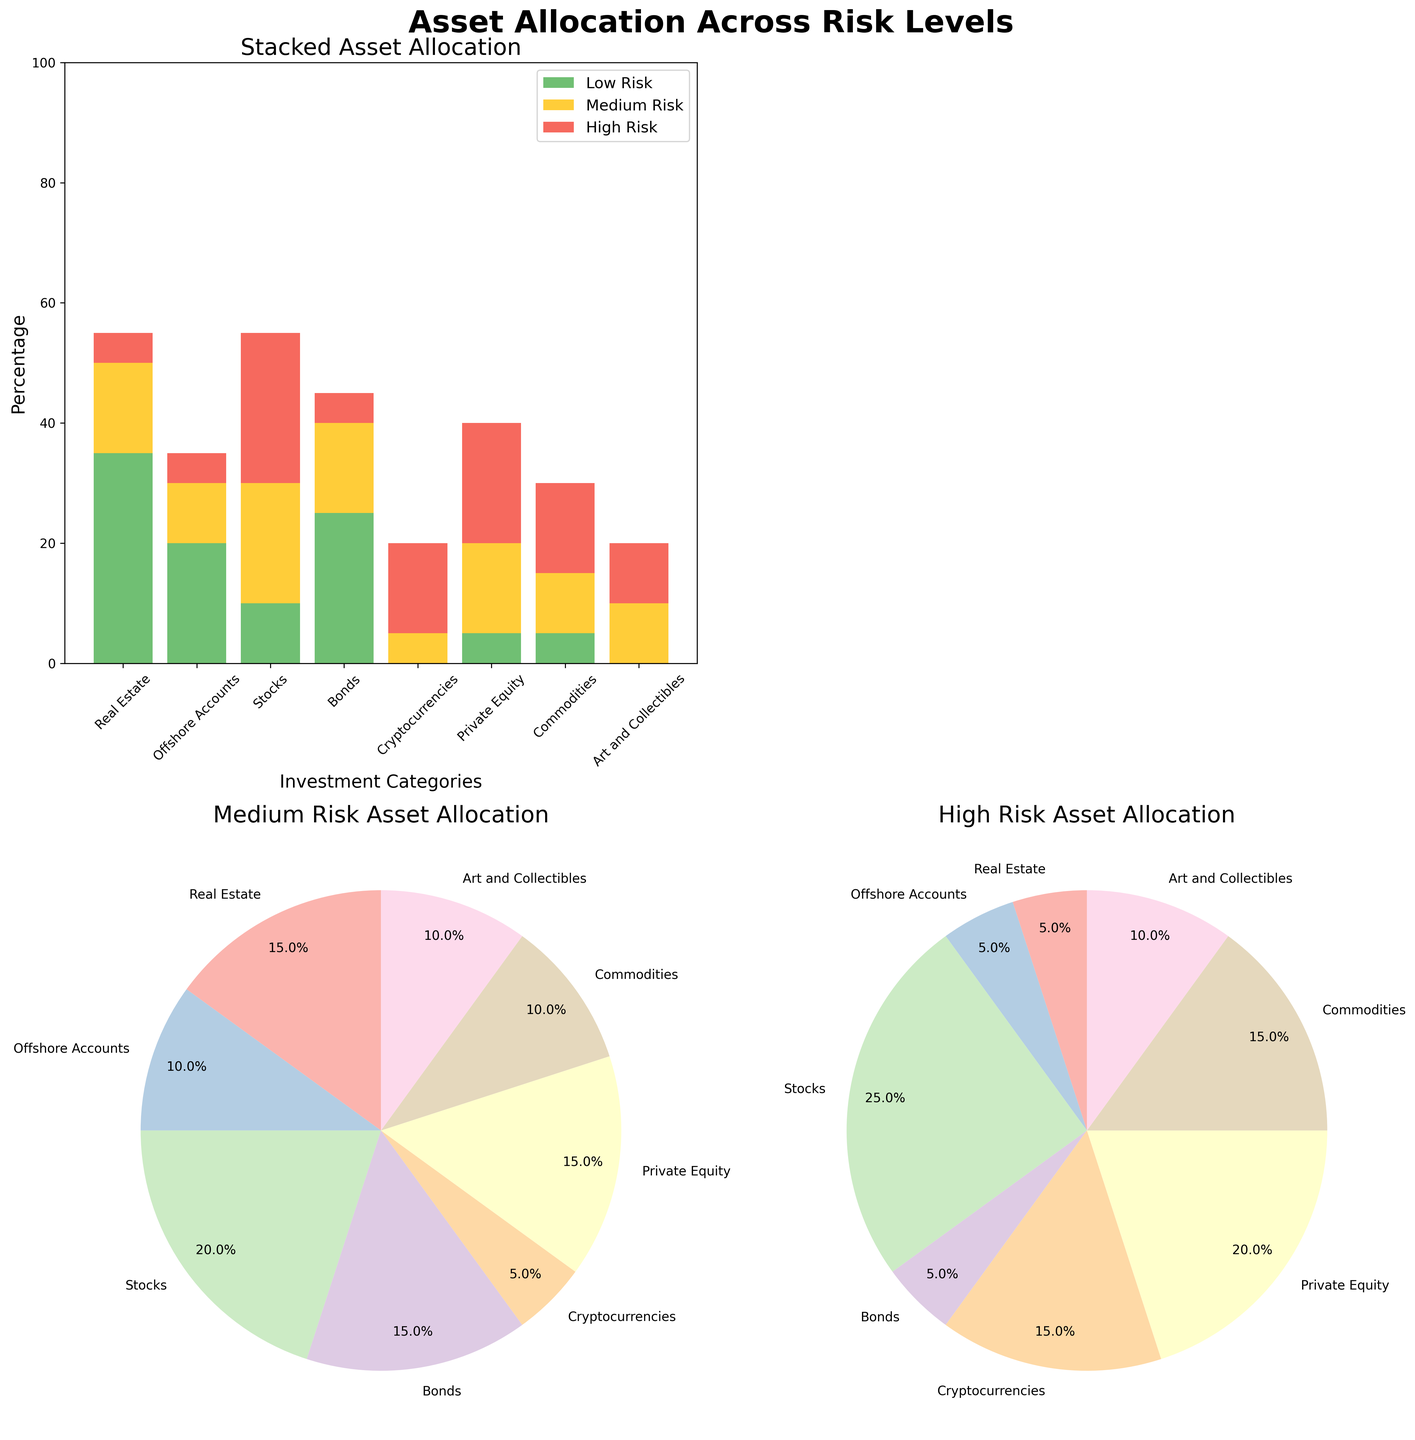What is the title of the figure? The title of the figure is usually at the top. Here, you'd see "Asset Allocation Across Risk Levels".
Answer: Asset Allocation Across Risk Levels In the stacked bar chart, which investment category has the highest allocation in low risk? By observing the lengths of the green bars (low-risk) in the stacked bar chart, Real Estate has the highest allocation.
Answer: Real Estate What percentage of Bonds is allocated to medium risk? In the stacked bar chart, the yellow segment for Bonds represents 15%.
Answer: 15% Which investment category has no allocation in the low-risk level? The green sections of bars not present indicate no allocation. Cryptocurrencies and Art and Collectibles have no green sections.
Answer: Cryptocurrencies and Art and Collectibles In the high-risk pie chart, which category has the largest slice? Checking the high-risk pie chart (bottom right), the largest slice corresponds to Stocks, given its significant share.
Answer: Stocks How does the allocation of medium risk in Private Equity compare to that in Commodities? Comparing the heights of the yellow bars in the stacked bar chart for Private Equity and Commodities, Private Equity has a larger medium risk allocation (15% vs. 10%).
Answer: Private Equity > Commodities If we combine the high-risk allocations of Real Estate and Stocks, how much would it total? Real Estate's high-risk is 5% and Stocks' is 25%. Summing these gives 5% + 25% = 30%.
Answer: 30% Which risk level has the highest total allocation across all investment categories? By observing and summing up the allocations in the stacked bar chart, low risk has the highest total (%) across all categories.
Answer: Low Risk Compare the pie chart slices of low risk and medium risk for Real Estate. Which is larger and by how much? The slice sizes for Real Estate in both pie charts indicate the sizes. Low risk (35%) is larger, and the difference is 35% - 15% = 20%.
Answer: Low Risk by 20% What is the total percentage allocation in high risk for all categories combined? Adding the high-risk percentages for each category from the figure: 5% (Real Estate) + 5% (Offshore Accounts) + 25% (Stocks) + 5% (Bonds) + 15% (Cryptocurrencies) + 20% (Private Equity) + 15% (Commodities) + 10% (Art and Collectibles) = 100%.
Answer: 100% 